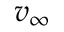Convert formula to latex. <formula><loc_0><loc_0><loc_500><loc_500>v _ { \infty }</formula> 